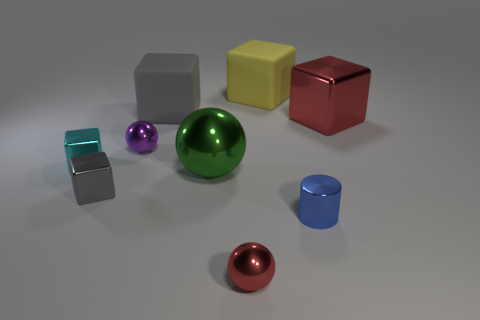Is there a metal ball that has the same color as the big metal block?
Offer a very short reply. Yes. How many large green metallic objects are in front of the red metallic thing to the right of the yellow rubber thing?
Your response must be concise. 1. There is a metal object that is both behind the cyan shiny block and right of the green shiny object; what is its size?
Provide a short and direct response. Large. What is the material of the tiny cube in front of the green ball?
Provide a short and direct response. Metal. Are there any large gray rubber objects of the same shape as the yellow object?
Your answer should be very brief. Yes. What number of big red objects have the same shape as the small purple thing?
Make the answer very short. 0. There is a shiny cube that is right of the small purple metal object; is it the same size as the gray thing that is behind the big metal block?
Provide a short and direct response. Yes. What shape is the red thing that is right of the large matte block to the right of the small red shiny sphere?
Provide a succinct answer. Cube. Are there the same number of small blue cylinders that are behind the big gray rubber object and big balls?
Offer a very short reply. No. What material is the gray cube that is in front of the sphere that is left of the big shiny object left of the large red object?
Keep it short and to the point. Metal. 